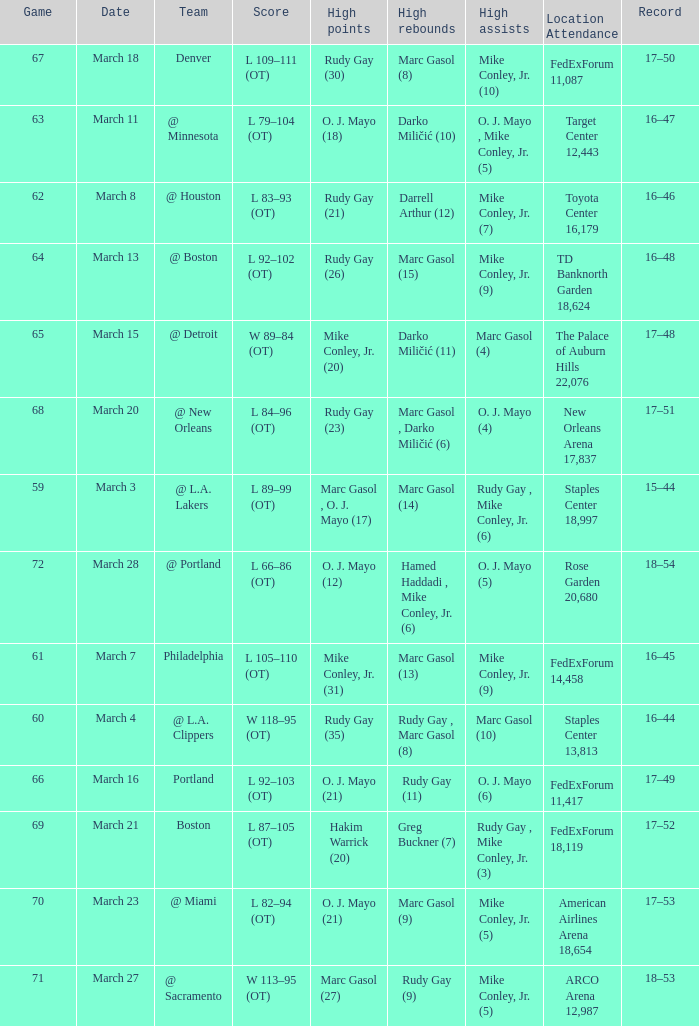What was the location and attendance for game 60? Staples Center 13,813. 